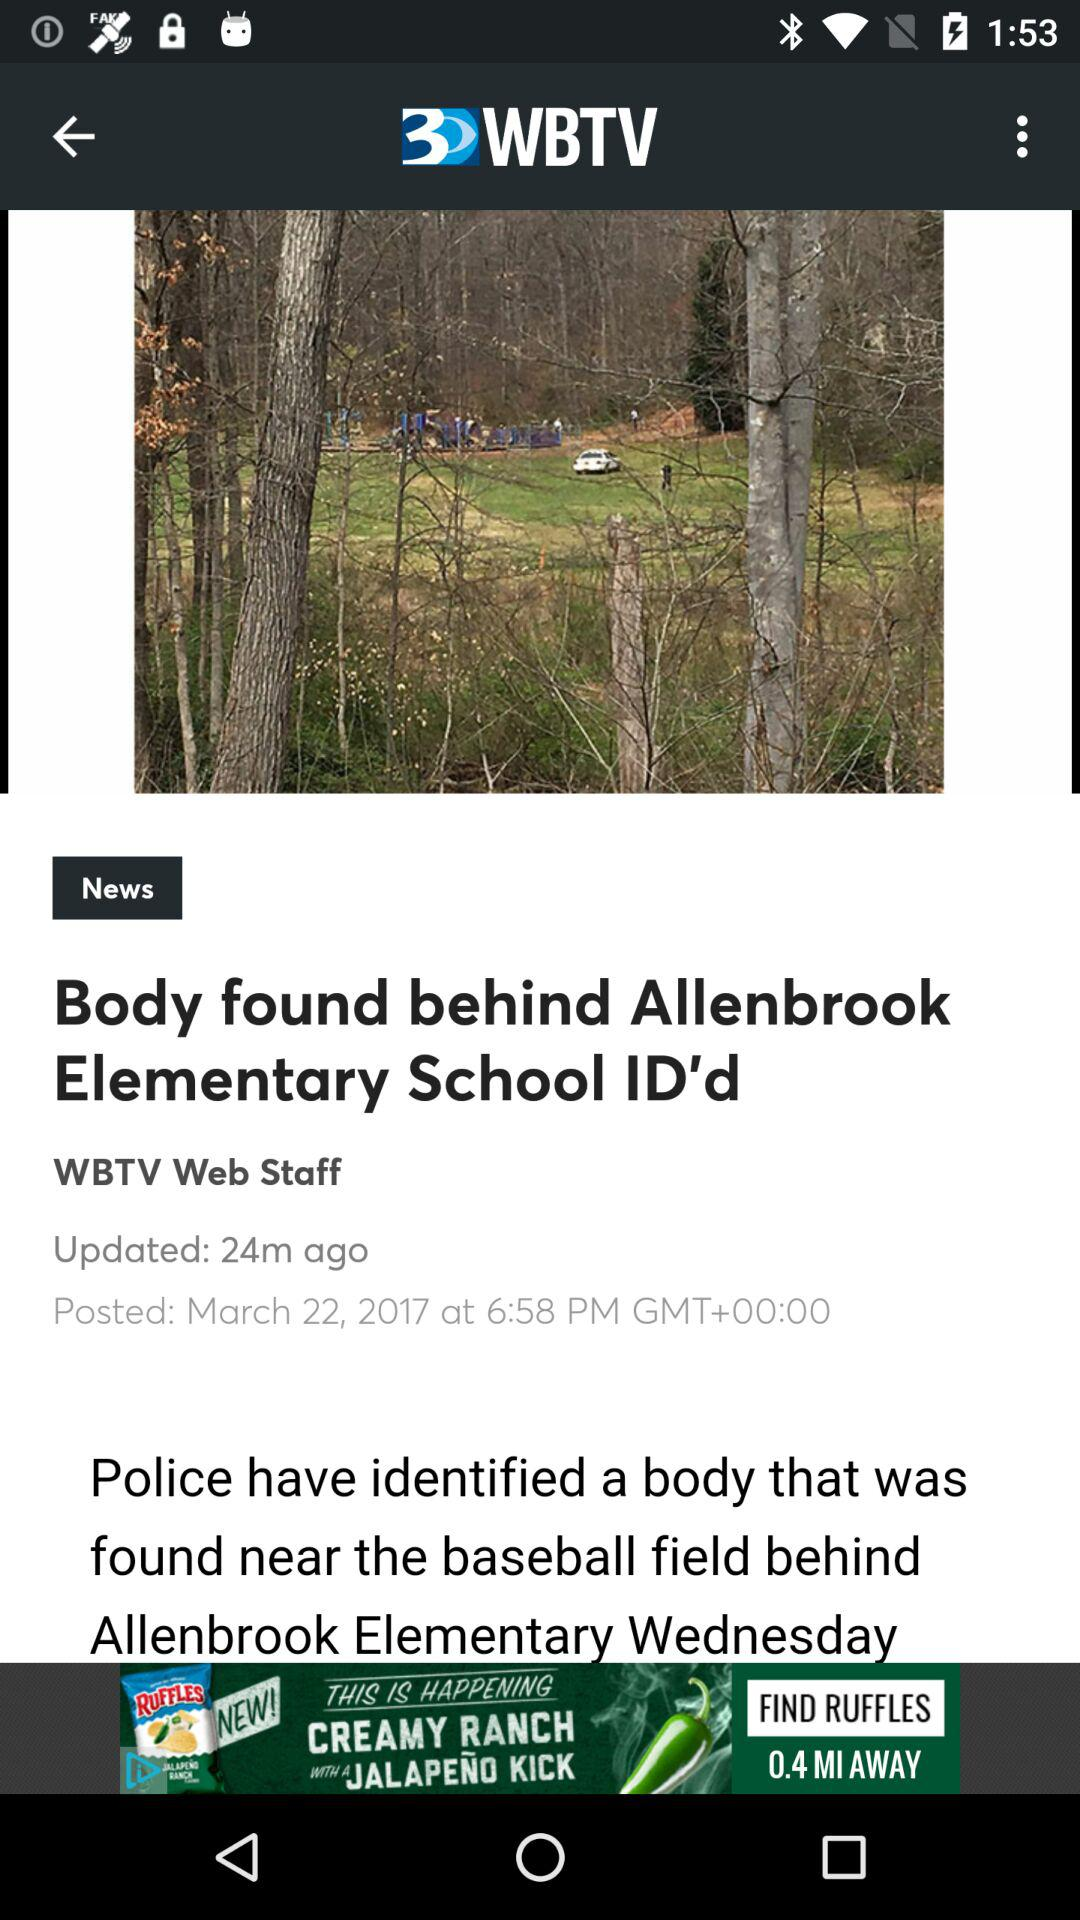When was the article posted? The article was posted March 22, 2017 at 6:58 p.m. in Greenwich Mean Time. 